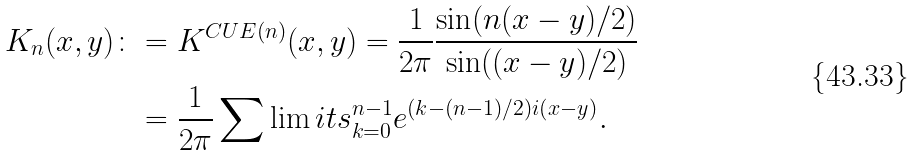Convert formula to latex. <formula><loc_0><loc_0><loc_500><loc_500>K _ { n } ( x , y ) \colon & = K ^ { C U E ( n ) } ( x , y ) = \frac { 1 } { 2 \pi } \frac { \sin ( n ( x - y ) / 2 ) } { \sin ( ( x - y ) / 2 ) } \\ & = \frac { 1 } { 2 \pi } \sum \lim i t s _ { k = 0 } ^ { n - 1 } e ^ { ( k - ( n - 1 ) / 2 ) i ( x - y ) } .</formula> 